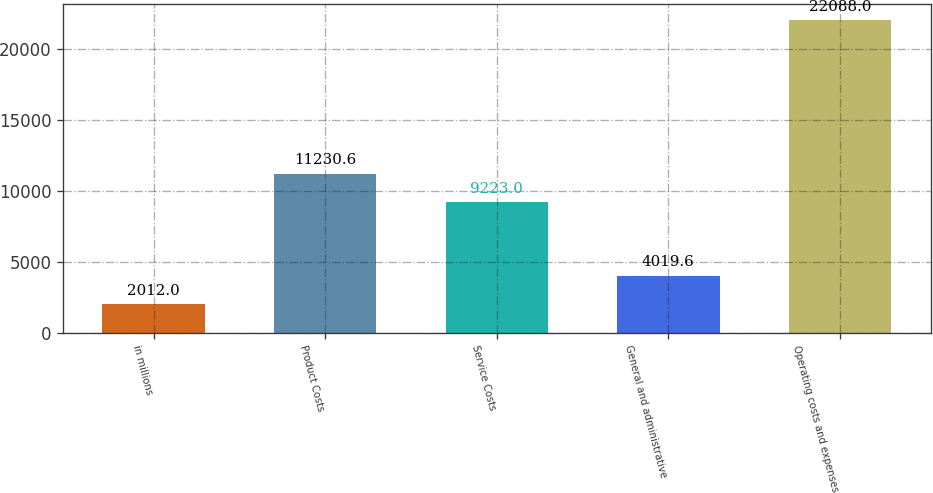<chart> <loc_0><loc_0><loc_500><loc_500><bar_chart><fcel>in millions<fcel>Product Costs<fcel>Service Costs<fcel>General and administrative<fcel>Operating costs and expenses<nl><fcel>2012<fcel>11230.6<fcel>9223<fcel>4019.6<fcel>22088<nl></chart> 